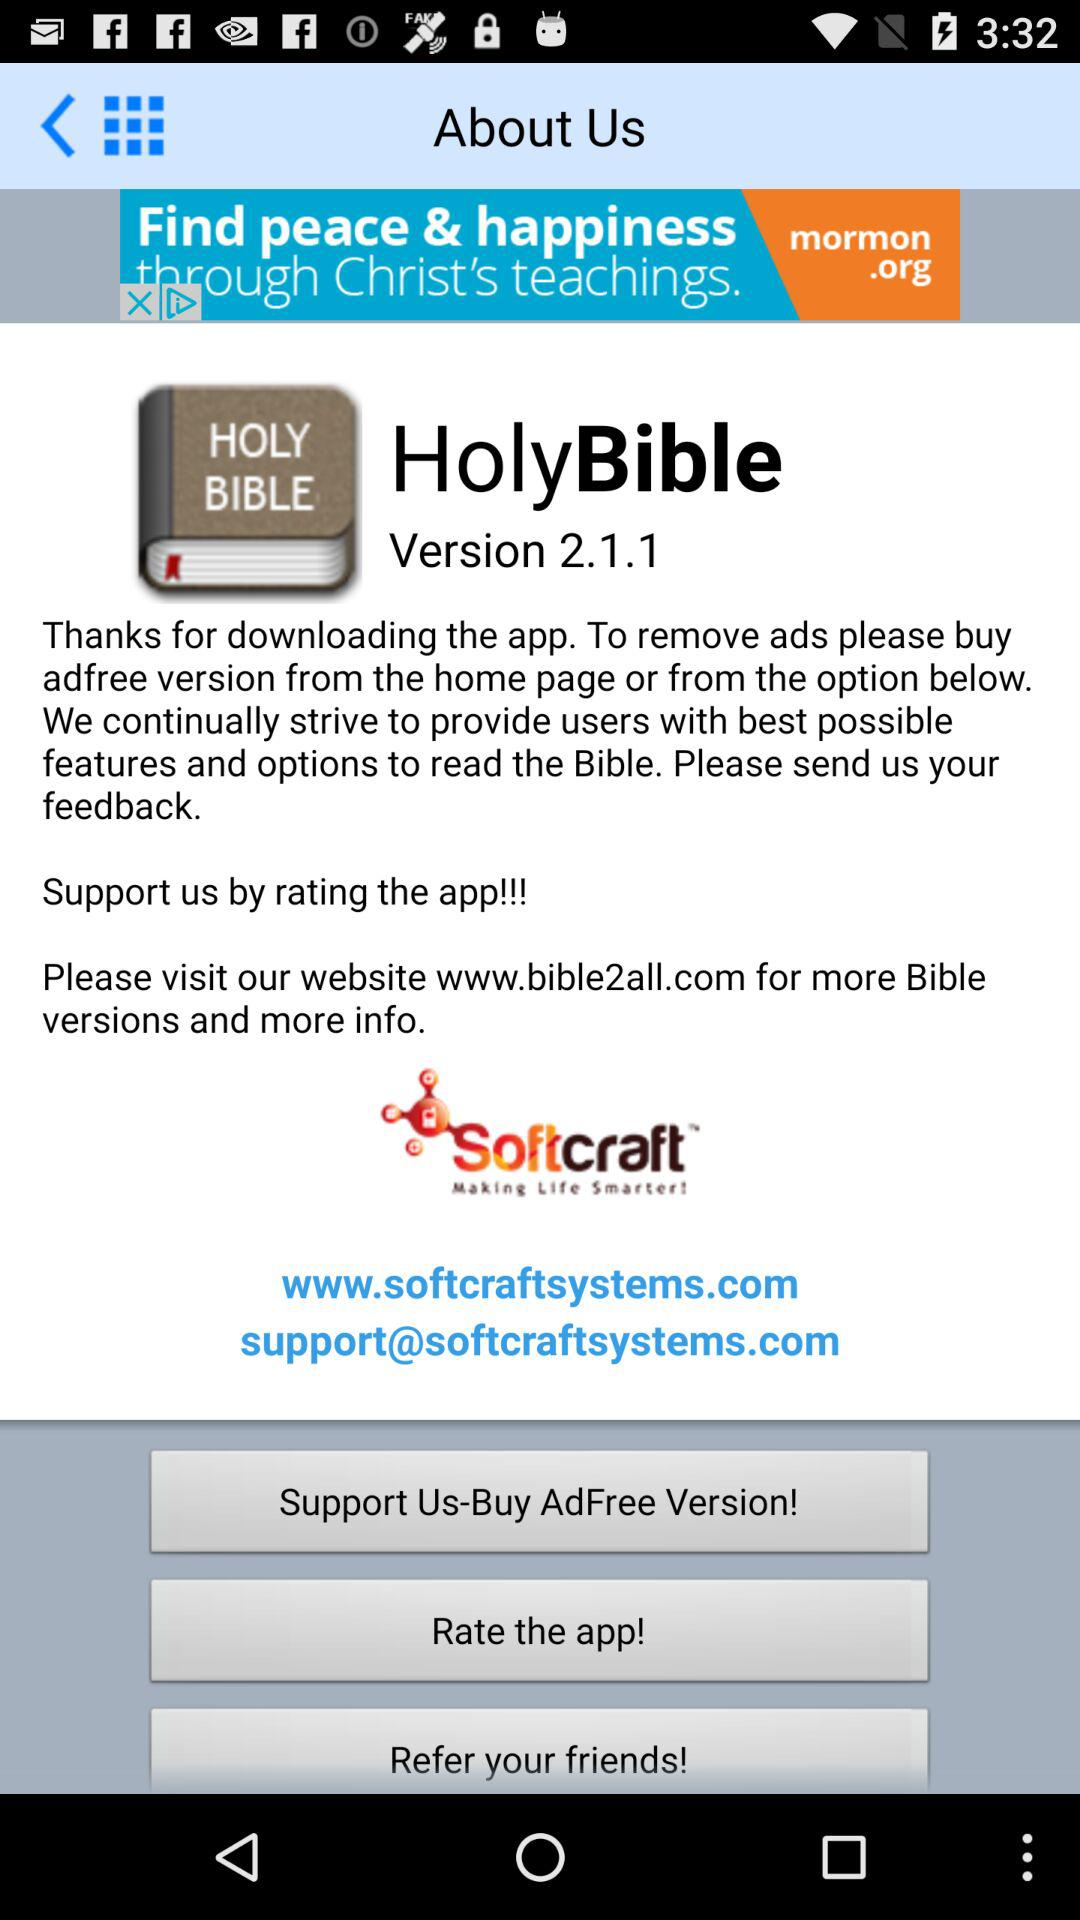What is the website's mail address? The website's mail address is support@softcraftsystems.com. 